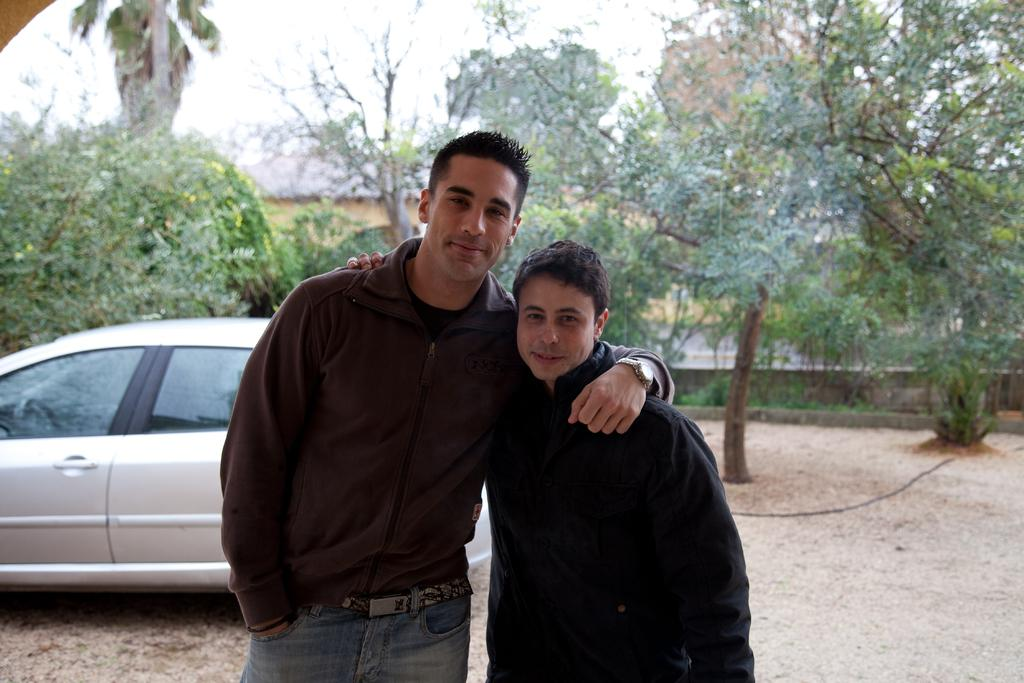How many men are present in the image? There are two men standing in the image. Can you describe the appearance of the man on the left side? The man on the left side is wearing a watch. What can be seen in the background of the image? There is a car, trees, a compound wall, and the sky visible in the background of the image. What type of gun is the man on the right side holding in the image? There is no gun present in the image; both men are standing without any visible weapons. 